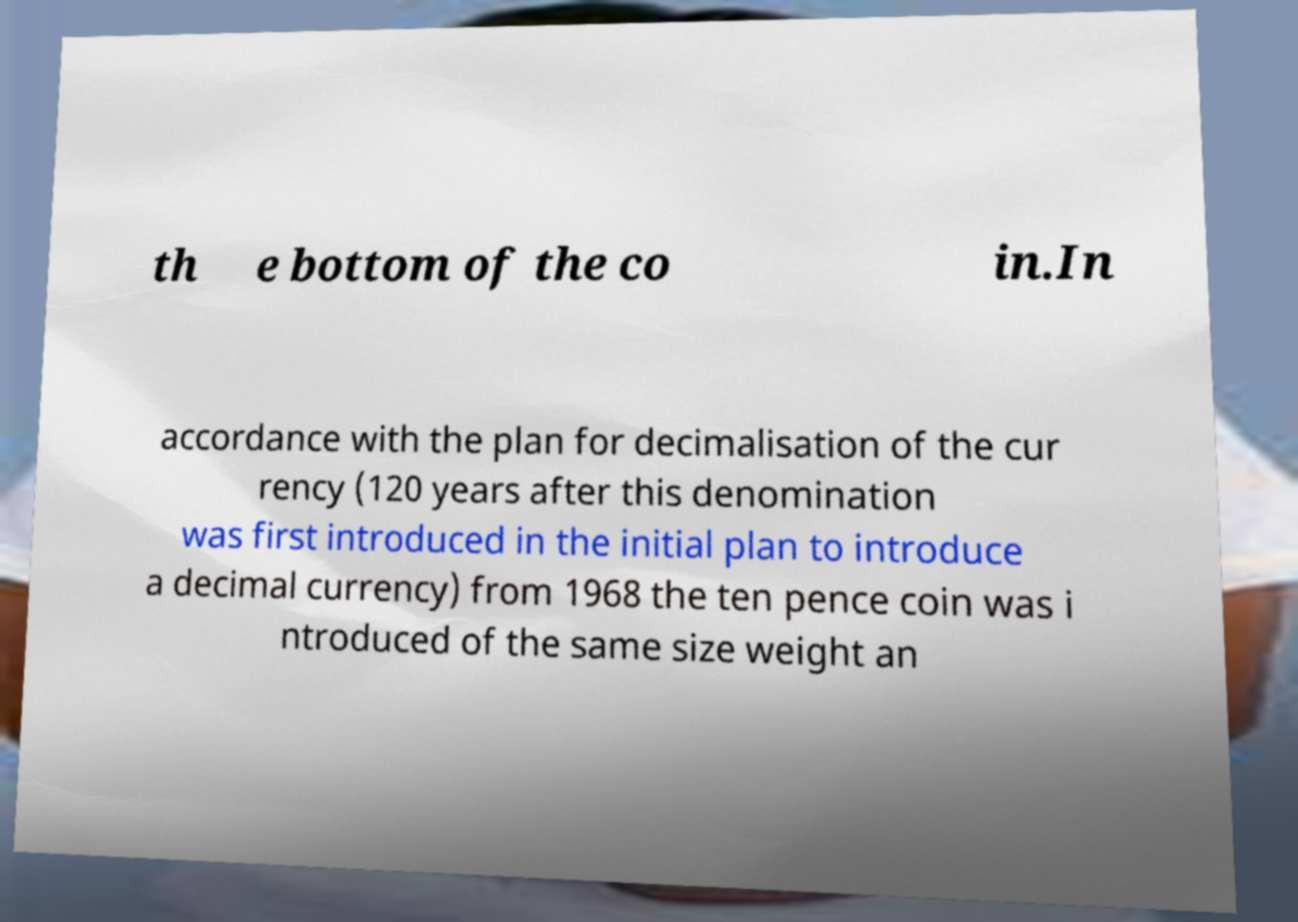Could you assist in decoding the text presented in this image and type it out clearly? th e bottom of the co in.In accordance with the plan for decimalisation of the cur rency (120 years after this denomination was first introduced in the initial plan to introduce a decimal currency) from 1968 the ten pence coin was i ntroduced of the same size weight an 